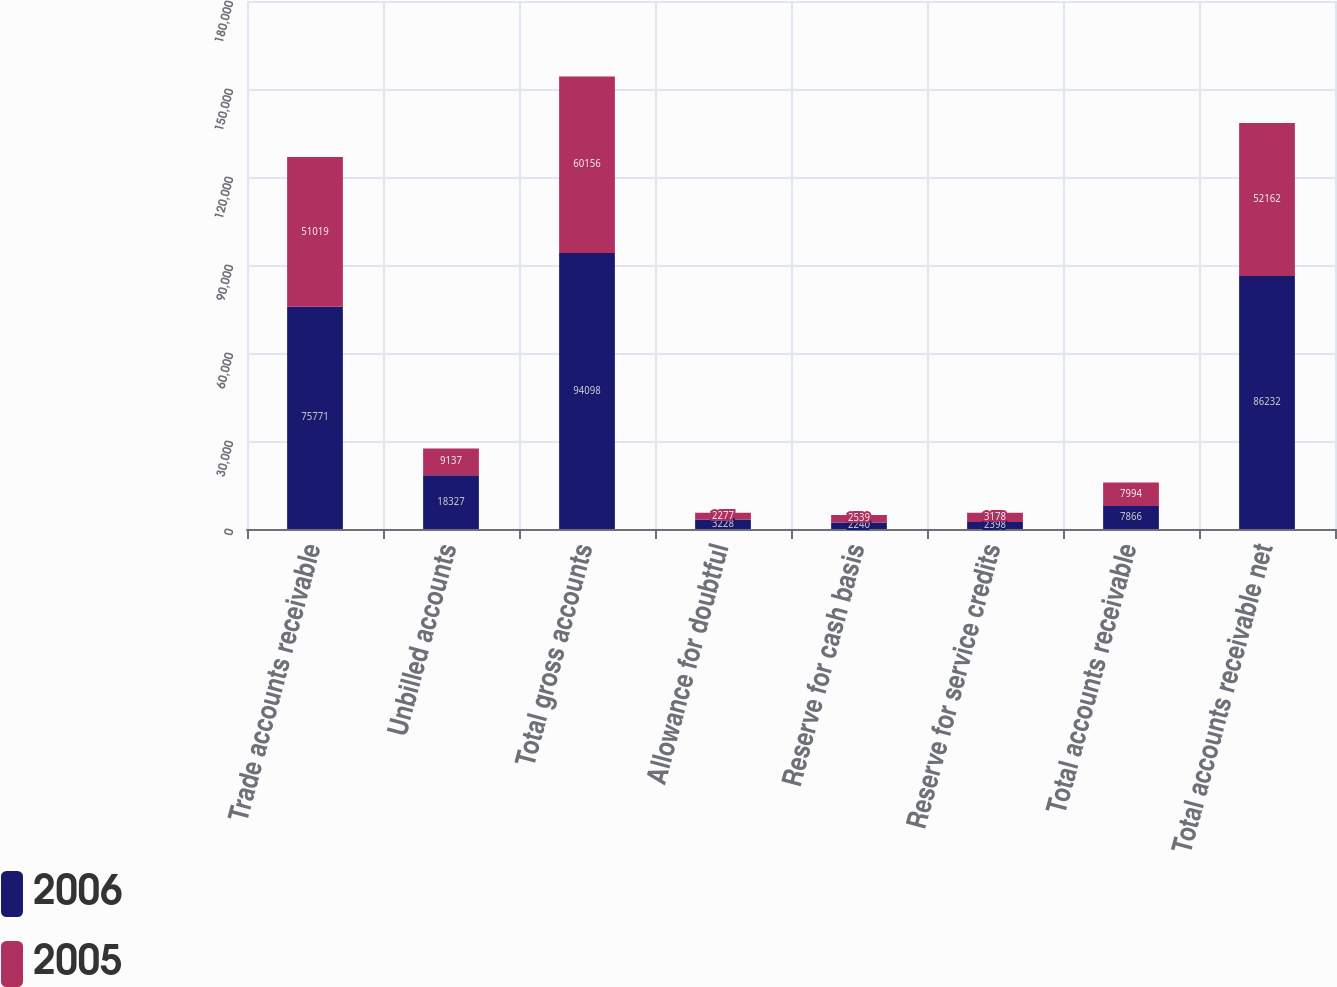Convert chart to OTSL. <chart><loc_0><loc_0><loc_500><loc_500><stacked_bar_chart><ecel><fcel>Trade accounts receivable<fcel>Unbilled accounts<fcel>Total gross accounts<fcel>Allowance for doubtful<fcel>Reserve for cash basis<fcel>Reserve for service credits<fcel>Total accounts receivable<fcel>Total accounts receivable net<nl><fcel>2006<fcel>75771<fcel>18327<fcel>94098<fcel>3228<fcel>2240<fcel>2398<fcel>7866<fcel>86232<nl><fcel>2005<fcel>51019<fcel>9137<fcel>60156<fcel>2277<fcel>2539<fcel>3178<fcel>7994<fcel>52162<nl></chart> 